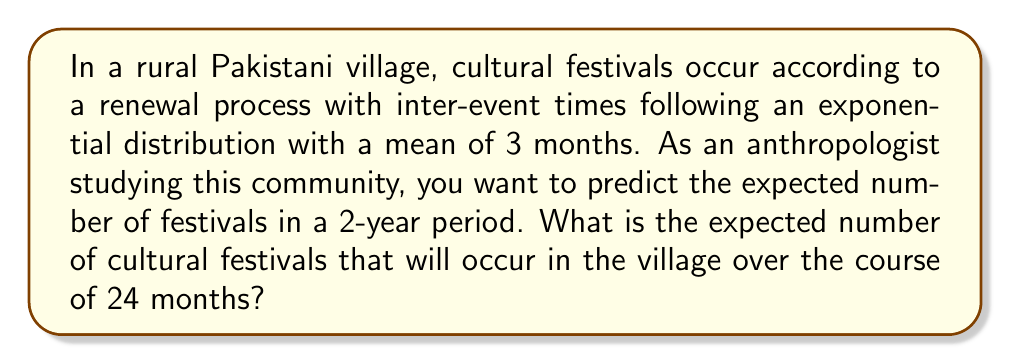Give your solution to this math problem. To solve this problem, we'll use the properties of renewal processes and the exponential distribution:

1. In a renewal process, the expected number of events $E[N(t)]$ in a time interval $t$ is given by:

   $$E[N(t)] = \frac{t}{E[X]}$$

   where $E[X]$ is the expected time between events.

2. We're given that the inter-event times follow an exponential distribution with a mean of 3 months. This means:

   $$E[X] = 3 \text{ months}$$

3. The time interval we're interested in is 24 months (2 years). So:

   $$t = 24 \text{ months}$$

4. Substituting these values into the formula:

   $$E[N(24)] = \frac{24}{3} = 8$$

5. Therefore, the expected number of cultural festivals in a 2-year period is 8.

This result aligns with intuition: if festivals occur on average every 3 months, we would expect about 4 festivals per year, or 8 festivals in 2 years.
Answer: 8 festivals 